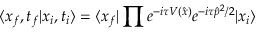Convert formula to latex. <formula><loc_0><loc_0><loc_500><loc_500>\langle x _ { f } , t _ { f } | x _ { i } , t _ { i } \rangle = \langle x _ { f } | \prod e ^ { - i \tau V ( \hat { x } ) } e ^ { - i \tau \hat { p } ^ { 2 } / 2 } | x _ { i } \rangle</formula> 